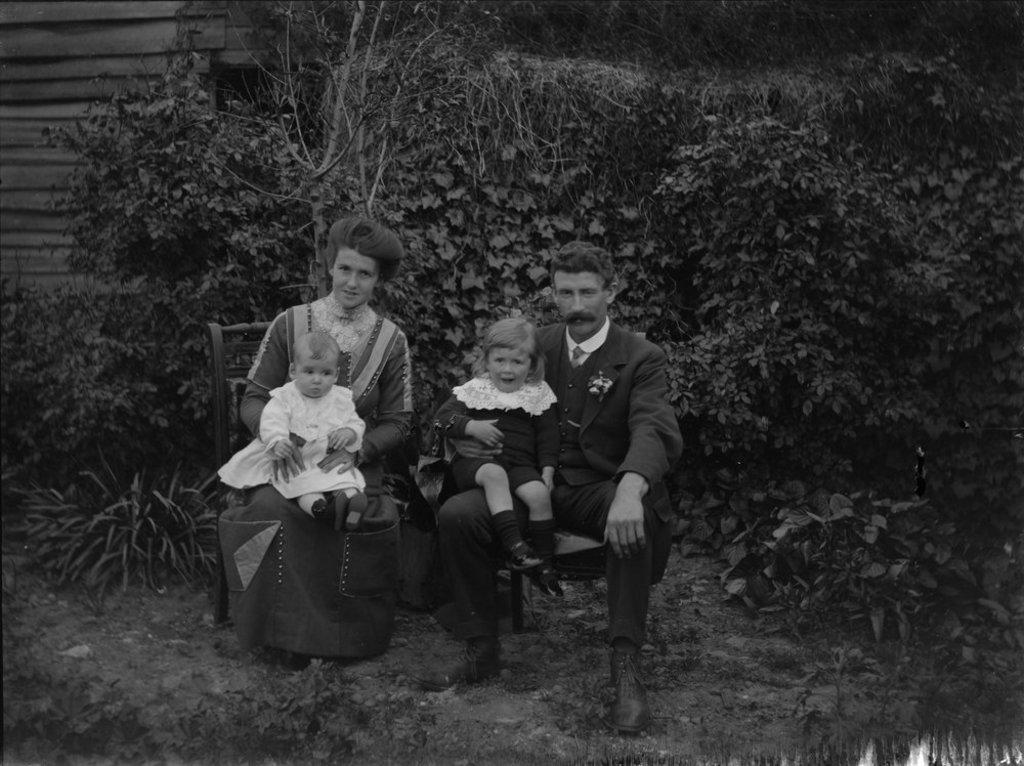Who is present in the family in the foreground of the picture? The family in the foreground of the picture consists of a man, a woman, and two kids. What else can be seen in the foreground of the picture besides the family? There are plants in the foreground of the picture. What can be seen in the background of the picture? There are trees and a building in the background of the picture. What type of jewel is the man wearing in the picture? There is no mention of any jewelry being worn by the man in the picture, so it cannot be determined from the image. 